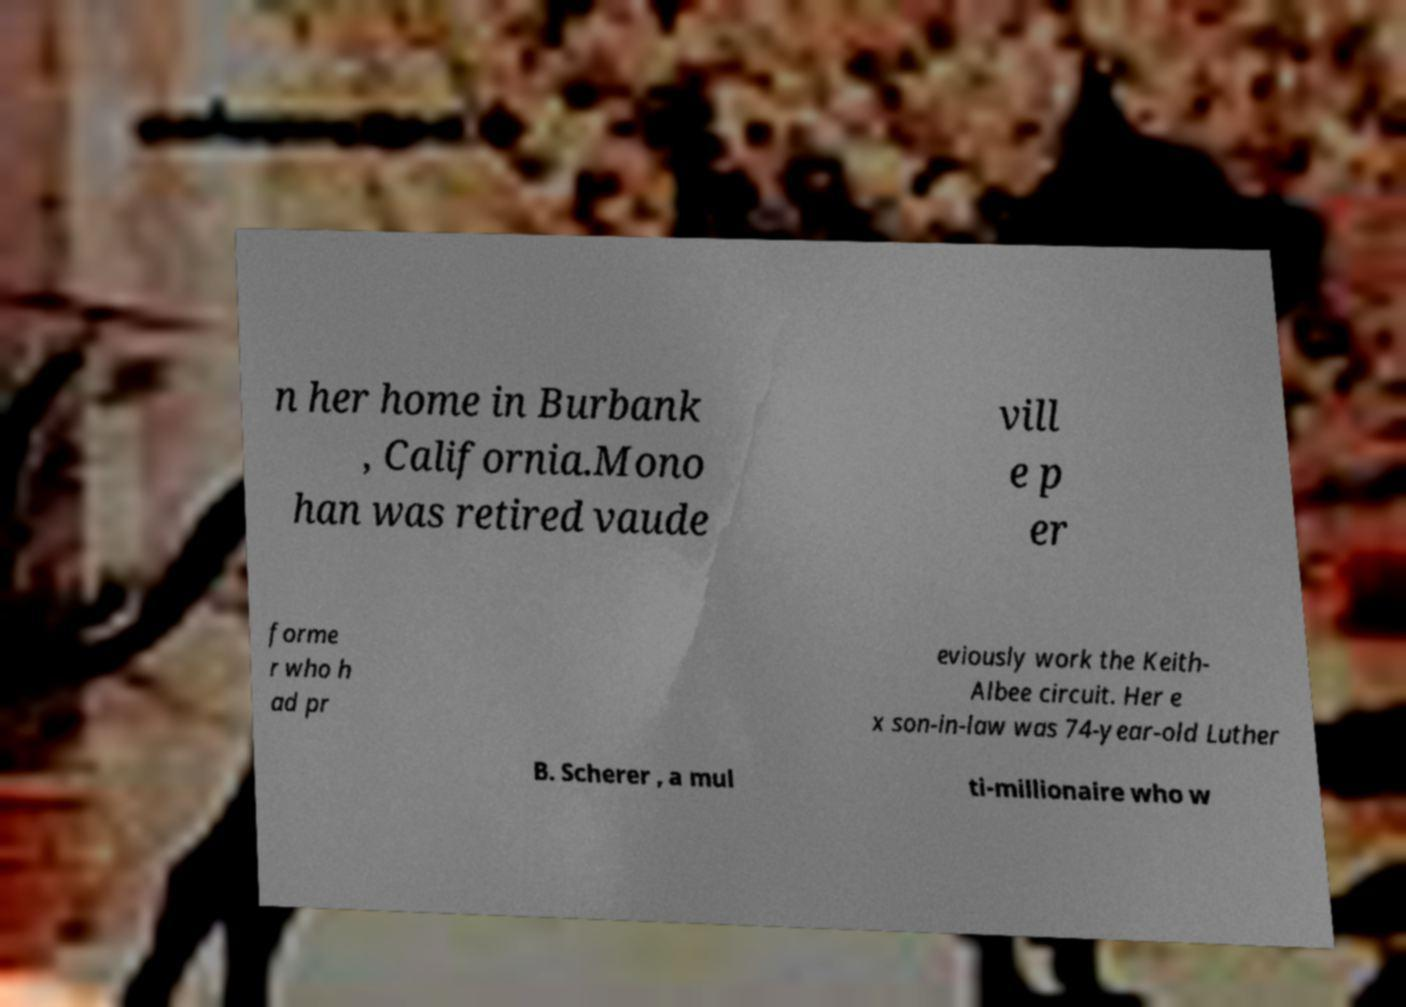There's text embedded in this image that I need extracted. Can you transcribe it verbatim? n her home in Burbank , California.Mono han was retired vaude vill e p er forme r who h ad pr eviously work the Keith- Albee circuit. Her e x son-in-law was 74-year-old Luther B. Scherer , a mul ti-millionaire who w 